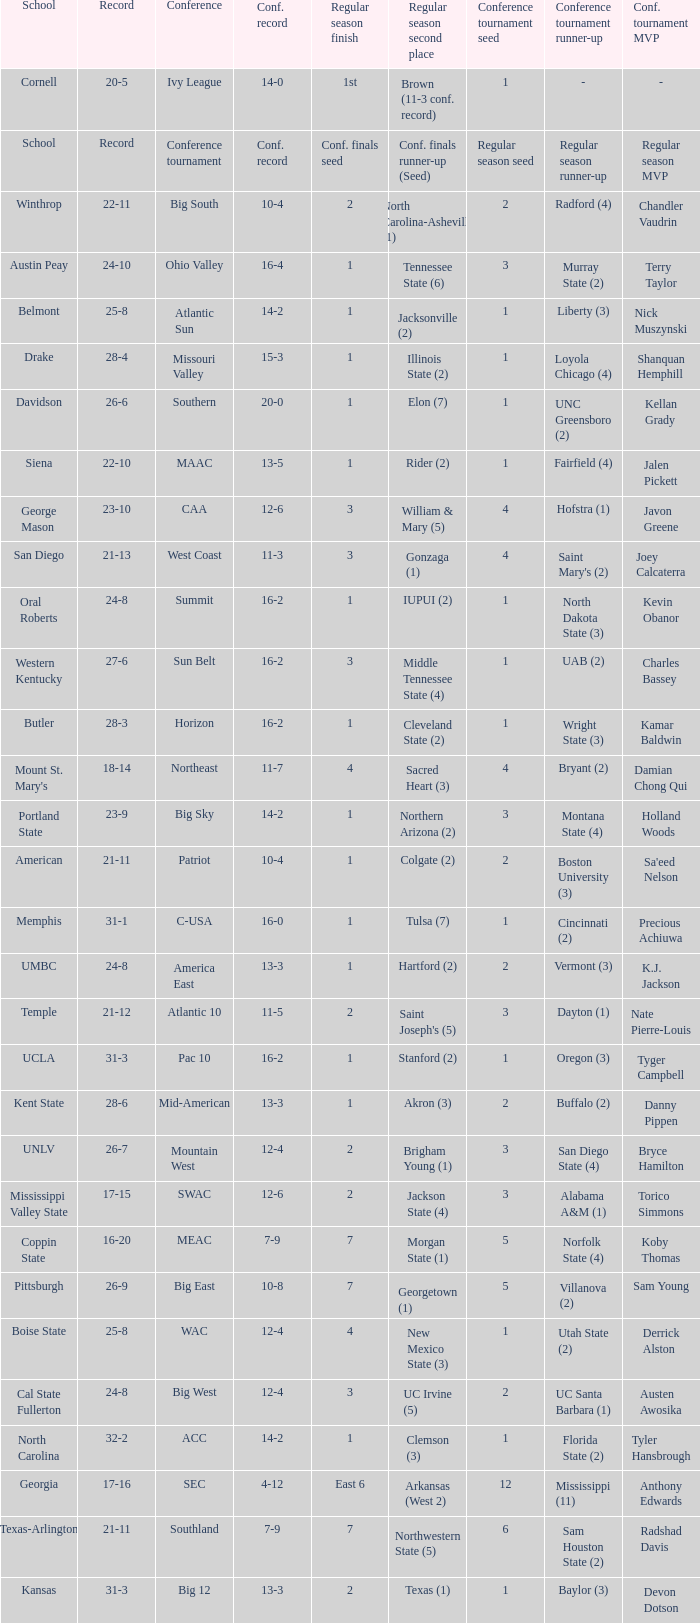Which conference is Belmont in? Atlantic Sun. 